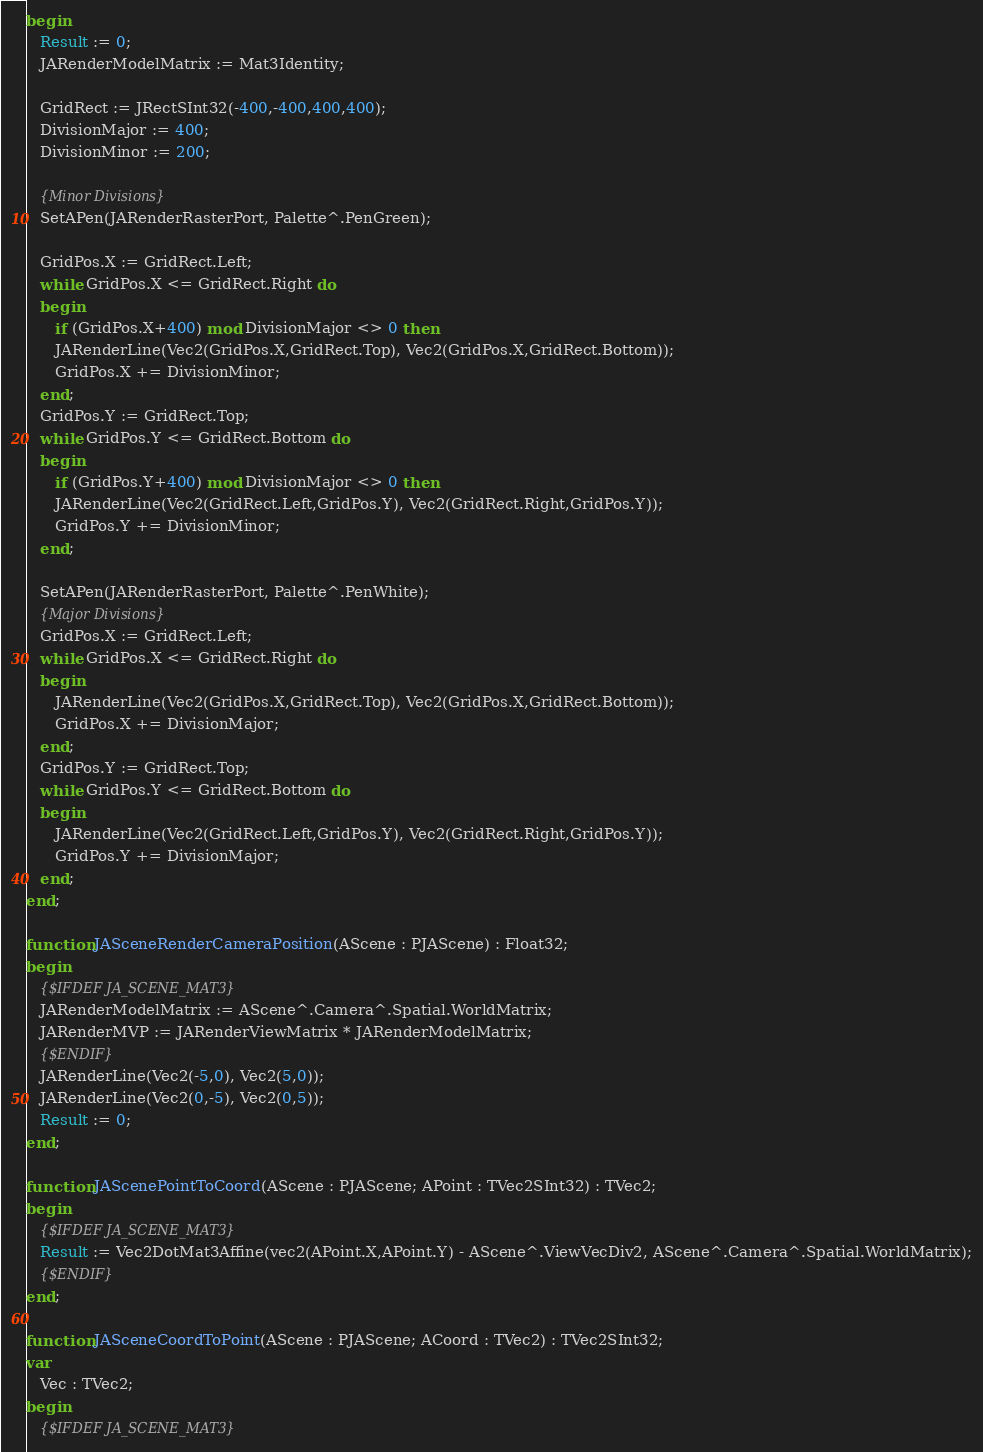Convert code to text. <code><loc_0><loc_0><loc_500><loc_500><_Pascal_>begin
   Result := 0;
   JARenderModelMatrix := Mat3Identity;

   GridRect := JRectSInt32(-400,-400,400,400);
   DivisionMajor := 400;
   DivisionMinor := 200;

   {Minor Divisions}
   SetAPen(JARenderRasterPort, Palette^.PenGreen);

   GridPos.X := GridRect.Left;
   while GridPos.X <= GridRect.Right do
   begin
      if (GridPos.X+400) mod DivisionMajor <> 0 then
      JARenderLine(Vec2(GridPos.X,GridRect.Top), Vec2(GridPos.X,GridRect.Bottom));
      GridPos.X += DivisionMinor;
   end;
   GridPos.Y := GridRect.Top;
   while GridPos.Y <= GridRect.Bottom do
   begin
      if (GridPos.Y+400) mod DivisionMajor <> 0 then
      JARenderLine(Vec2(GridRect.Left,GridPos.Y), Vec2(GridRect.Right,GridPos.Y));
      GridPos.Y += DivisionMinor;
   end;

   SetAPen(JARenderRasterPort, Palette^.PenWhite);
   {Major Divisions}
   GridPos.X := GridRect.Left;
   while GridPos.X <= GridRect.Right do
   begin
      JARenderLine(Vec2(GridPos.X,GridRect.Top), Vec2(GridPos.X,GridRect.Bottom));
      GridPos.X += DivisionMajor;
   end;
   GridPos.Y := GridRect.Top;
   while GridPos.Y <= GridRect.Bottom do
   begin
      JARenderLine(Vec2(GridRect.Left,GridPos.Y), Vec2(GridRect.Right,GridPos.Y));
      GridPos.Y += DivisionMajor;
   end;
end;

function JASceneRenderCameraPosition(AScene : PJAScene) : Float32;
begin
   {$IFDEF JA_SCENE_MAT3}
   JARenderModelMatrix := AScene^.Camera^.Spatial.WorldMatrix;
   JARenderMVP := JARenderViewMatrix * JARenderModelMatrix;
   {$ENDIF}
   JARenderLine(Vec2(-5,0), Vec2(5,0));
   JARenderLine(Vec2(0,-5), Vec2(0,5));
   Result := 0;
end;

function JAScenePointToCoord(AScene : PJAScene; APoint : TVec2SInt32) : TVec2;
begin
   {$IFDEF JA_SCENE_MAT3}
   Result := Vec2DotMat3Affine(vec2(APoint.X,APoint.Y) - AScene^.ViewVecDiv2, AScene^.Camera^.Spatial.WorldMatrix);
   {$ENDIF}
end;

function JASceneCoordToPoint(AScene : PJAScene; ACoord : TVec2) : TVec2SInt32;
var
   Vec : TVec2;
begin
   {$IFDEF JA_SCENE_MAT3}</code> 